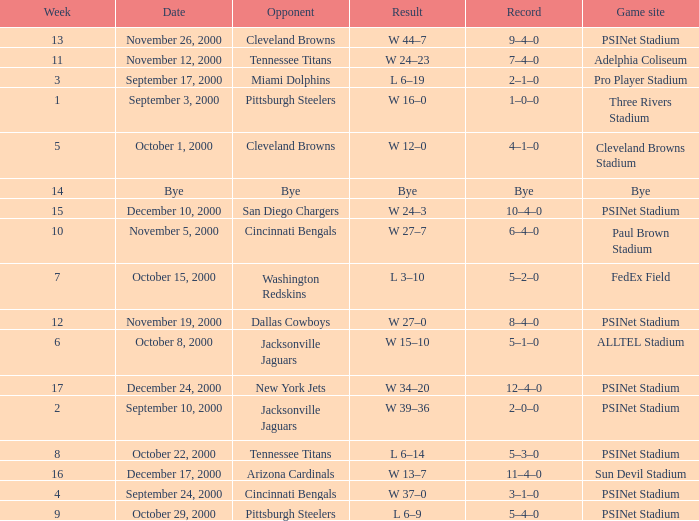What's the record after week 12 with a game site of bye? Bye. 